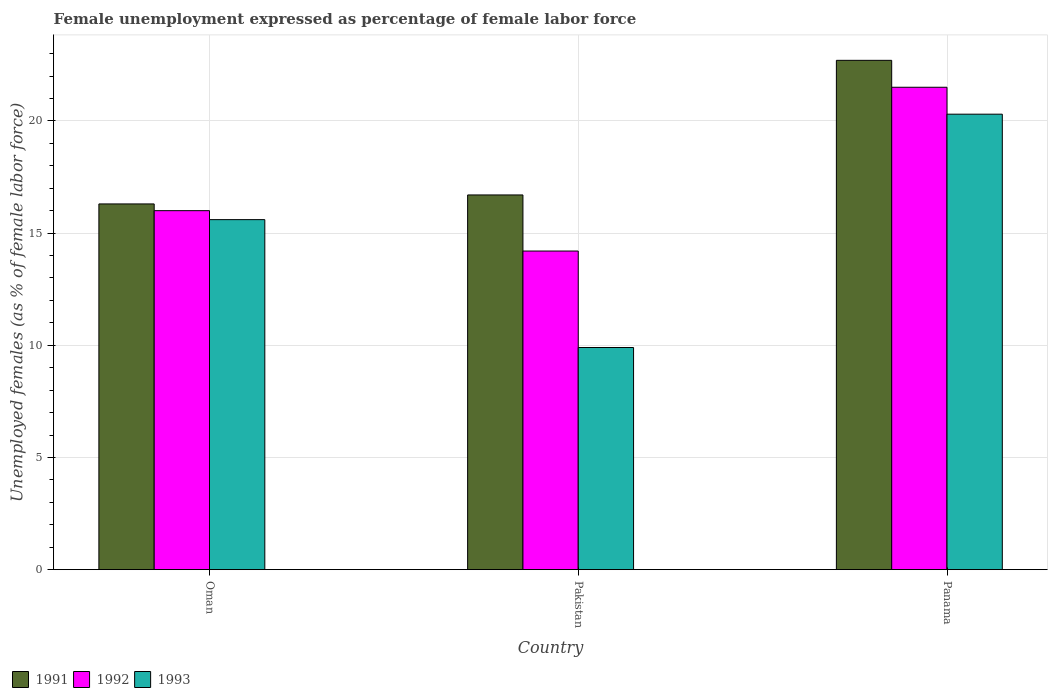How many bars are there on the 2nd tick from the left?
Offer a very short reply. 3. What is the label of the 3rd group of bars from the left?
Make the answer very short. Panama. What is the unemployment in females in in 1991 in Pakistan?
Keep it short and to the point. 16.7. Across all countries, what is the minimum unemployment in females in in 1991?
Keep it short and to the point. 16.3. In which country was the unemployment in females in in 1993 maximum?
Give a very brief answer. Panama. What is the total unemployment in females in in 1991 in the graph?
Offer a terse response. 55.7. What is the difference between the unemployment in females in in 1992 in Oman and that in Pakistan?
Keep it short and to the point. 1.8. What is the difference between the unemployment in females in in 1993 in Oman and the unemployment in females in in 1992 in Pakistan?
Keep it short and to the point. 1.4. What is the average unemployment in females in in 1992 per country?
Ensure brevity in your answer.  17.23. What is the difference between the unemployment in females in of/in 1993 and unemployment in females in of/in 1992 in Panama?
Offer a very short reply. -1.2. What is the ratio of the unemployment in females in in 1992 in Oman to that in Pakistan?
Give a very brief answer. 1.13. Is the unemployment in females in in 1993 in Oman less than that in Panama?
Your answer should be compact. Yes. Is the difference between the unemployment in females in in 1993 in Oman and Panama greater than the difference between the unemployment in females in in 1992 in Oman and Panama?
Your answer should be compact. Yes. What is the difference between the highest and the lowest unemployment in females in in 1992?
Your response must be concise. 7.3. What does the 2nd bar from the left in Pakistan represents?
Your answer should be very brief. 1992. Is it the case that in every country, the sum of the unemployment in females in in 1993 and unemployment in females in in 1992 is greater than the unemployment in females in in 1991?
Offer a terse response. Yes. How many bars are there?
Your response must be concise. 9. How many countries are there in the graph?
Offer a terse response. 3. Are the values on the major ticks of Y-axis written in scientific E-notation?
Your answer should be very brief. No. Where does the legend appear in the graph?
Make the answer very short. Bottom left. What is the title of the graph?
Give a very brief answer. Female unemployment expressed as percentage of female labor force. What is the label or title of the X-axis?
Keep it short and to the point. Country. What is the label or title of the Y-axis?
Offer a very short reply. Unemployed females (as % of female labor force). What is the Unemployed females (as % of female labor force) in 1991 in Oman?
Offer a terse response. 16.3. What is the Unemployed females (as % of female labor force) of 1993 in Oman?
Make the answer very short. 15.6. What is the Unemployed females (as % of female labor force) in 1991 in Pakistan?
Your answer should be very brief. 16.7. What is the Unemployed females (as % of female labor force) in 1992 in Pakistan?
Offer a terse response. 14.2. What is the Unemployed females (as % of female labor force) in 1993 in Pakistan?
Your answer should be very brief. 9.9. What is the Unemployed females (as % of female labor force) in 1991 in Panama?
Make the answer very short. 22.7. What is the Unemployed females (as % of female labor force) of 1992 in Panama?
Your response must be concise. 21.5. What is the Unemployed females (as % of female labor force) of 1993 in Panama?
Give a very brief answer. 20.3. Across all countries, what is the maximum Unemployed females (as % of female labor force) in 1991?
Your answer should be very brief. 22.7. Across all countries, what is the maximum Unemployed females (as % of female labor force) of 1993?
Keep it short and to the point. 20.3. Across all countries, what is the minimum Unemployed females (as % of female labor force) in 1991?
Give a very brief answer. 16.3. Across all countries, what is the minimum Unemployed females (as % of female labor force) in 1992?
Your answer should be very brief. 14.2. Across all countries, what is the minimum Unemployed females (as % of female labor force) in 1993?
Offer a terse response. 9.9. What is the total Unemployed females (as % of female labor force) in 1991 in the graph?
Keep it short and to the point. 55.7. What is the total Unemployed females (as % of female labor force) of 1992 in the graph?
Your answer should be compact. 51.7. What is the total Unemployed females (as % of female labor force) of 1993 in the graph?
Ensure brevity in your answer.  45.8. What is the difference between the Unemployed females (as % of female labor force) of 1991 in Oman and that in Pakistan?
Keep it short and to the point. -0.4. What is the difference between the Unemployed females (as % of female labor force) in 1992 in Oman and that in Pakistan?
Provide a short and direct response. 1.8. What is the difference between the Unemployed females (as % of female labor force) in 1991 in Oman and that in Panama?
Keep it short and to the point. -6.4. What is the difference between the Unemployed females (as % of female labor force) of 1992 in Oman and that in Panama?
Keep it short and to the point. -5.5. What is the difference between the Unemployed females (as % of female labor force) of 1991 in Oman and the Unemployed females (as % of female labor force) of 1993 in Pakistan?
Offer a very short reply. 6.4. What is the difference between the Unemployed females (as % of female labor force) in 1992 in Oman and the Unemployed females (as % of female labor force) in 1993 in Pakistan?
Make the answer very short. 6.1. What is the difference between the Unemployed females (as % of female labor force) of 1991 in Oman and the Unemployed females (as % of female labor force) of 1992 in Panama?
Your answer should be compact. -5.2. What is the difference between the Unemployed females (as % of female labor force) in 1992 in Oman and the Unemployed females (as % of female labor force) in 1993 in Panama?
Give a very brief answer. -4.3. What is the difference between the Unemployed females (as % of female labor force) in 1992 in Pakistan and the Unemployed females (as % of female labor force) in 1993 in Panama?
Keep it short and to the point. -6.1. What is the average Unemployed females (as % of female labor force) of 1991 per country?
Your response must be concise. 18.57. What is the average Unemployed females (as % of female labor force) in 1992 per country?
Offer a very short reply. 17.23. What is the average Unemployed females (as % of female labor force) of 1993 per country?
Provide a short and direct response. 15.27. What is the difference between the Unemployed females (as % of female labor force) in 1991 and Unemployed females (as % of female labor force) in 1993 in Oman?
Give a very brief answer. 0.7. What is the difference between the Unemployed females (as % of female labor force) of 1992 and Unemployed females (as % of female labor force) of 1993 in Oman?
Ensure brevity in your answer.  0.4. What is the difference between the Unemployed females (as % of female labor force) in 1991 and Unemployed females (as % of female labor force) in 1992 in Pakistan?
Your response must be concise. 2.5. What is the difference between the Unemployed females (as % of female labor force) of 1991 and Unemployed females (as % of female labor force) of 1993 in Pakistan?
Your response must be concise. 6.8. What is the difference between the Unemployed females (as % of female labor force) in 1991 and Unemployed females (as % of female labor force) in 1992 in Panama?
Provide a short and direct response. 1.2. What is the difference between the Unemployed females (as % of female labor force) in 1991 and Unemployed females (as % of female labor force) in 1993 in Panama?
Keep it short and to the point. 2.4. What is the difference between the Unemployed females (as % of female labor force) in 1992 and Unemployed females (as % of female labor force) in 1993 in Panama?
Keep it short and to the point. 1.2. What is the ratio of the Unemployed females (as % of female labor force) in 1991 in Oman to that in Pakistan?
Your answer should be compact. 0.98. What is the ratio of the Unemployed females (as % of female labor force) in 1992 in Oman to that in Pakistan?
Your response must be concise. 1.13. What is the ratio of the Unemployed females (as % of female labor force) of 1993 in Oman to that in Pakistan?
Give a very brief answer. 1.58. What is the ratio of the Unemployed females (as % of female labor force) in 1991 in Oman to that in Panama?
Your answer should be compact. 0.72. What is the ratio of the Unemployed females (as % of female labor force) in 1992 in Oman to that in Panama?
Offer a very short reply. 0.74. What is the ratio of the Unemployed females (as % of female labor force) of 1993 in Oman to that in Panama?
Provide a succinct answer. 0.77. What is the ratio of the Unemployed females (as % of female labor force) in 1991 in Pakistan to that in Panama?
Your response must be concise. 0.74. What is the ratio of the Unemployed females (as % of female labor force) of 1992 in Pakistan to that in Panama?
Provide a short and direct response. 0.66. What is the ratio of the Unemployed females (as % of female labor force) in 1993 in Pakistan to that in Panama?
Give a very brief answer. 0.49. What is the difference between the highest and the second highest Unemployed females (as % of female labor force) of 1991?
Your answer should be compact. 6. What is the difference between the highest and the second highest Unemployed females (as % of female labor force) in 1992?
Your response must be concise. 5.5. What is the difference between the highest and the lowest Unemployed females (as % of female labor force) of 1991?
Your answer should be compact. 6.4. 